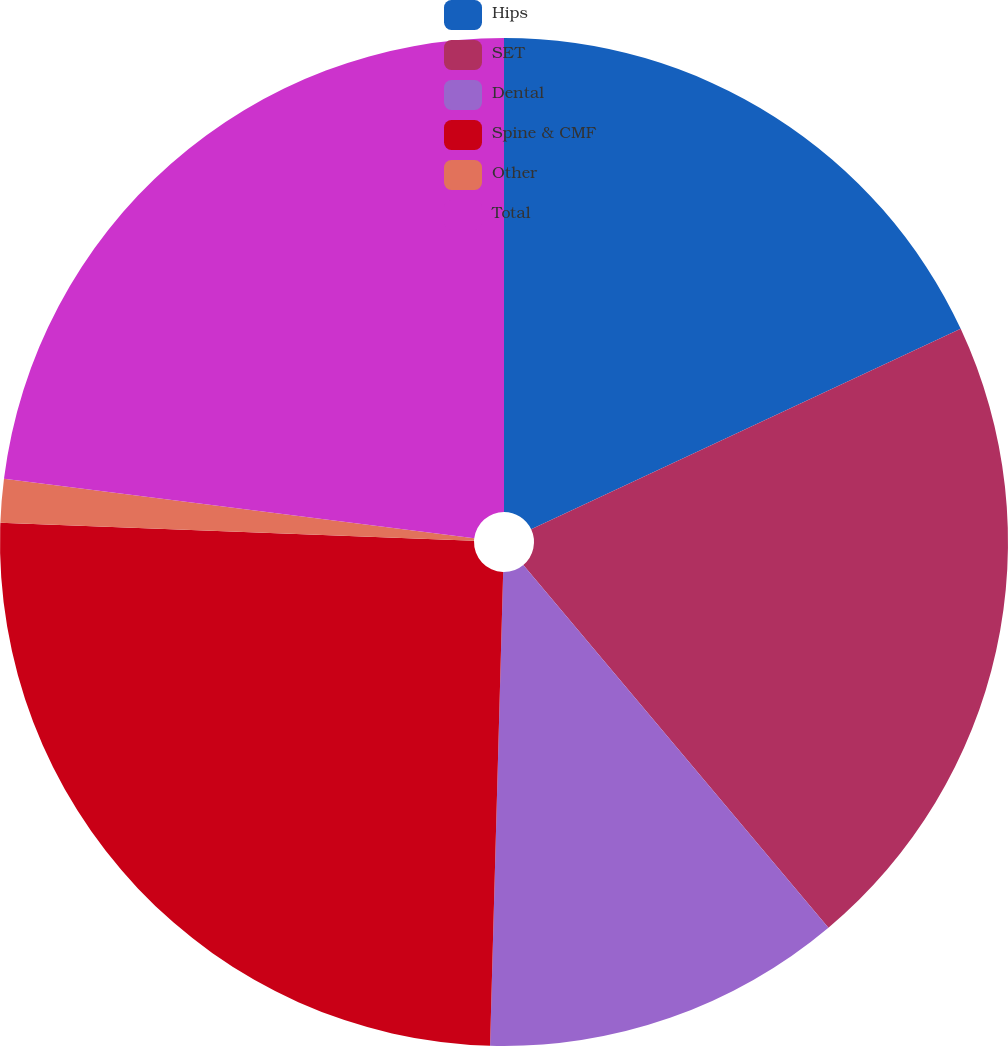Convert chart to OTSL. <chart><loc_0><loc_0><loc_500><loc_500><pie_chart><fcel>Hips<fcel>SET<fcel>Dental<fcel>Spine & CMF<fcel>Other<fcel>Total<nl><fcel>18.05%<fcel>20.82%<fcel>11.57%<fcel>25.17%<fcel>1.39%<fcel>23.0%<nl></chart> 